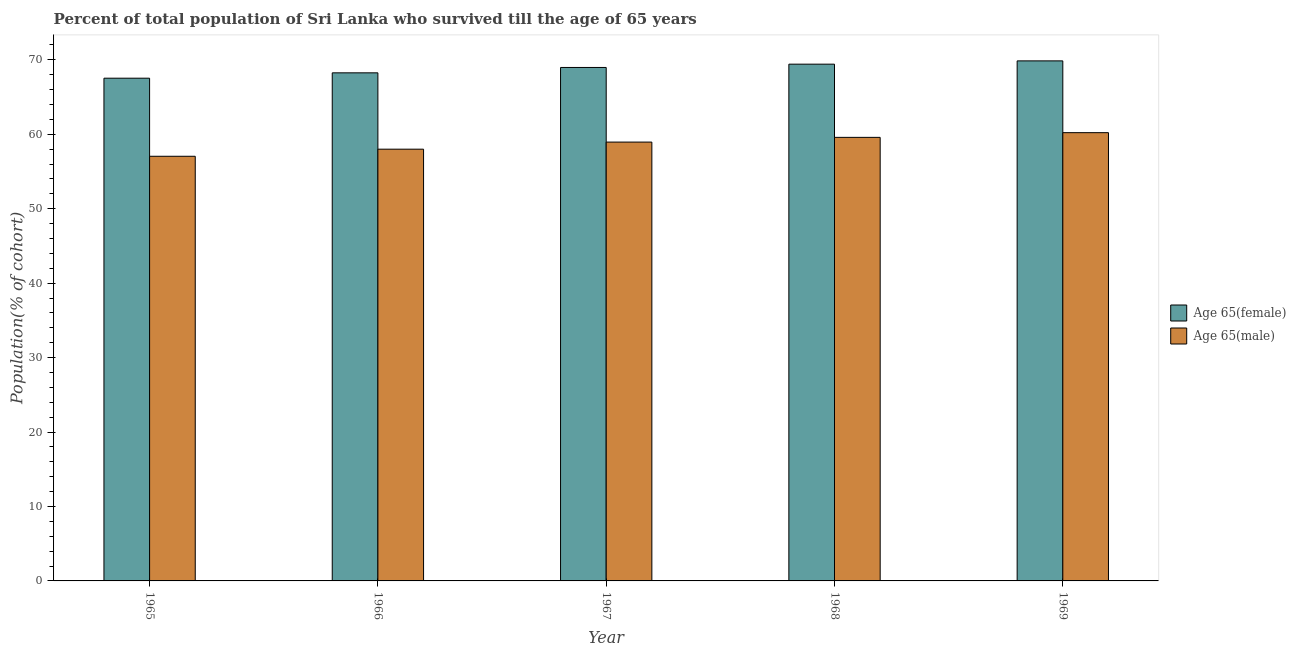How many different coloured bars are there?
Offer a very short reply. 2. How many groups of bars are there?
Give a very brief answer. 5. How many bars are there on the 3rd tick from the right?
Your answer should be compact. 2. What is the label of the 1st group of bars from the left?
Give a very brief answer. 1965. In how many cases, is the number of bars for a given year not equal to the number of legend labels?
Keep it short and to the point. 0. What is the percentage of male population who survived till age of 65 in 1965?
Your answer should be very brief. 57.04. Across all years, what is the maximum percentage of male population who survived till age of 65?
Your answer should be compact. 60.21. Across all years, what is the minimum percentage of female population who survived till age of 65?
Keep it short and to the point. 67.53. In which year was the percentage of male population who survived till age of 65 maximum?
Your response must be concise. 1969. In which year was the percentage of male population who survived till age of 65 minimum?
Your answer should be very brief. 1965. What is the total percentage of female population who survived till age of 65 in the graph?
Your response must be concise. 344.03. What is the difference between the percentage of male population who survived till age of 65 in 1967 and that in 1968?
Offer a very short reply. -0.63. What is the difference between the percentage of male population who survived till age of 65 in 1966 and the percentage of female population who survived till age of 65 in 1967?
Your response must be concise. -0.95. What is the average percentage of male population who survived till age of 65 per year?
Provide a short and direct response. 58.76. In how many years, is the percentage of female population who survived till age of 65 greater than 24 %?
Keep it short and to the point. 5. What is the ratio of the percentage of female population who survived till age of 65 in 1966 to that in 1968?
Your answer should be compact. 0.98. What is the difference between the highest and the second highest percentage of female population who survived till age of 65?
Your answer should be very brief. 0.44. What is the difference between the highest and the lowest percentage of male population who survived till age of 65?
Your response must be concise. 3.17. What does the 2nd bar from the left in 1965 represents?
Your answer should be compact. Age 65(male). What does the 2nd bar from the right in 1965 represents?
Make the answer very short. Age 65(female). Are all the bars in the graph horizontal?
Your answer should be very brief. No. Are the values on the major ticks of Y-axis written in scientific E-notation?
Give a very brief answer. No. Does the graph contain any zero values?
Your answer should be compact. No. How many legend labels are there?
Your answer should be compact. 2. How are the legend labels stacked?
Provide a short and direct response. Vertical. What is the title of the graph?
Offer a terse response. Percent of total population of Sri Lanka who survived till the age of 65 years. Does "Private credit bureau" appear as one of the legend labels in the graph?
Ensure brevity in your answer.  No. What is the label or title of the X-axis?
Offer a terse response. Year. What is the label or title of the Y-axis?
Offer a terse response. Population(% of cohort). What is the Population(% of cohort) in Age 65(female) in 1965?
Provide a short and direct response. 67.53. What is the Population(% of cohort) in Age 65(male) in 1965?
Provide a succinct answer. 57.04. What is the Population(% of cohort) in Age 65(female) in 1966?
Keep it short and to the point. 68.25. What is the Population(% of cohort) of Age 65(male) in 1966?
Your response must be concise. 58. What is the Population(% of cohort) of Age 65(female) in 1967?
Provide a succinct answer. 68.97. What is the Population(% of cohort) of Age 65(male) in 1967?
Provide a succinct answer. 58.95. What is the Population(% of cohort) of Age 65(female) in 1968?
Ensure brevity in your answer.  69.42. What is the Population(% of cohort) of Age 65(male) in 1968?
Give a very brief answer. 59.58. What is the Population(% of cohort) in Age 65(female) in 1969?
Your response must be concise. 69.86. What is the Population(% of cohort) in Age 65(male) in 1969?
Keep it short and to the point. 60.21. Across all years, what is the maximum Population(% of cohort) of Age 65(female)?
Your answer should be very brief. 69.86. Across all years, what is the maximum Population(% of cohort) in Age 65(male)?
Make the answer very short. 60.21. Across all years, what is the minimum Population(% of cohort) in Age 65(female)?
Your response must be concise. 67.53. Across all years, what is the minimum Population(% of cohort) in Age 65(male)?
Offer a terse response. 57.04. What is the total Population(% of cohort) in Age 65(female) in the graph?
Offer a terse response. 344.03. What is the total Population(% of cohort) of Age 65(male) in the graph?
Your answer should be compact. 293.79. What is the difference between the Population(% of cohort) in Age 65(female) in 1965 and that in 1966?
Provide a succinct answer. -0.72. What is the difference between the Population(% of cohort) in Age 65(male) in 1965 and that in 1966?
Provide a short and direct response. -0.95. What is the difference between the Population(% of cohort) of Age 65(female) in 1965 and that in 1967?
Offer a very short reply. -1.44. What is the difference between the Population(% of cohort) of Age 65(male) in 1965 and that in 1967?
Your answer should be very brief. -1.9. What is the difference between the Population(% of cohort) of Age 65(female) in 1965 and that in 1968?
Ensure brevity in your answer.  -1.88. What is the difference between the Population(% of cohort) of Age 65(male) in 1965 and that in 1968?
Give a very brief answer. -2.54. What is the difference between the Population(% of cohort) of Age 65(female) in 1965 and that in 1969?
Make the answer very short. -2.33. What is the difference between the Population(% of cohort) of Age 65(male) in 1965 and that in 1969?
Offer a terse response. -3.17. What is the difference between the Population(% of cohort) of Age 65(female) in 1966 and that in 1967?
Ensure brevity in your answer.  -0.72. What is the difference between the Population(% of cohort) in Age 65(male) in 1966 and that in 1967?
Provide a succinct answer. -0.95. What is the difference between the Population(% of cohort) of Age 65(female) in 1966 and that in 1968?
Ensure brevity in your answer.  -1.16. What is the difference between the Population(% of cohort) of Age 65(male) in 1966 and that in 1968?
Offer a terse response. -1.59. What is the difference between the Population(% of cohort) of Age 65(female) in 1966 and that in 1969?
Provide a short and direct response. -1.61. What is the difference between the Population(% of cohort) of Age 65(male) in 1966 and that in 1969?
Give a very brief answer. -2.22. What is the difference between the Population(% of cohort) in Age 65(female) in 1967 and that in 1968?
Give a very brief answer. -0.44. What is the difference between the Population(% of cohort) in Age 65(male) in 1967 and that in 1968?
Your answer should be compact. -0.63. What is the difference between the Population(% of cohort) in Age 65(female) in 1967 and that in 1969?
Provide a succinct answer. -0.88. What is the difference between the Population(% of cohort) in Age 65(male) in 1967 and that in 1969?
Ensure brevity in your answer.  -1.27. What is the difference between the Population(% of cohort) of Age 65(female) in 1968 and that in 1969?
Ensure brevity in your answer.  -0.44. What is the difference between the Population(% of cohort) in Age 65(male) in 1968 and that in 1969?
Your response must be concise. -0.63. What is the difference between the Population(% of cohort) in Age 65(female) in 1965 and the Population(% of cohort) in Age 65(male) in 1966?
Make the answer very short. 9.53. What is the difference between the Population(% of cohort) in Age 65(female) in 1965 and the Population(% of cohort) in Age 65(male) in 1967?
Your answer should be very brief. 8.58. What is the difference between the Population(% of cohort) of Age 65(female) in 1965 and the Population(% of cohort) of Age 65(male) in 1968?
Provide a succinct answer. 7.95. What is the difference between the Population(% of cohort) in Age 65(female) in 1965 and the Population(% of cohort) in Age 65(male) in 1969?
Ensure brevity in your answer.  7.32. What is the difference between the Population(% of cohort) in Age 65(female) in 1966 and the Population(% of cohort) in Age 65(male) in 1967?
Offer a very short reply. 9.3. What is the difference between the Population(% of cohort) of Age 65(female) in 1966 and the Population(% of cohort) of Age 65(male) in 1968?
Ensure brevity in your answer.  8.67. What is the difference between the Population(% of cohort) of Age 65(female) in 1966 and the Population(% of cohort) of Age 65(male) in 1969?
Give a very brief answer. 8.04. What is the difference between the Population(% of cohort) in Age 65(female) in 1967 and the Population(% of cohort) in Age 65(male) in 1968?
Give a very brief answer. 9.39. What is the difference between the Population(% of cohort) of Age 65(female) in 1967 and the Population(% of cohort) of Age 65(male) in 1969?
Provide a short and direct response. 8.76. What is the difference between the Population(% of cohort) of Age 65(female) in 1968 and the Population(% of cohort) of Age 65(male) in 1969?
Ensure brevity in your answer.  9.2. What is the average Population(% of cohort) in Age 65(female) per year?
Give a very brief answer. 68.81. What is the average Population(% of cohort) of Age 65(male) per year?
Offer a terse response. 58.76. In the year 1965, what is the difference between the Population(% of cohort) in Age 65(female) and Population(% of cohort) in Age 65(male)?
Provide a succinct answer. 10.49. In the year 1966, what is the difference between the Population(% of cohort) of Age 65(female) and Population(% of cohort) of Age 65(male)?
Keep it short and to the point. 10.26. In the year 1967, what is the difference between the Population(% of cohort) in Age 65(female) and Population(% of cohort) in Age 65(male)?
Offer a terse response. 10.02. In the year 1968, what is the difference between the Population(% of cohort) in Age 65(female) and Population(% of cohort) in Age 65(male)?
Make the answer very short. 9.83. In the year 1969, what is the difference between the Population(% of cohort) in Age 65(female) and Population(% of cohort) in Age 65(male)?
Offer a very short reply. 9.64. What is the ratio of the Population(% of cohort) in Age 65(male) in 1965 to that in 1966?
Ensure brevity in your answer.  0.98. What is the ratio of the Population(% of cohort) of Age 65(female) in 1965 to that in 1967?
Your response must be concise. 0.98. What is the ratio of the Population(% of cohort) in Age 65(female) in 1965 to that in 1968?
Provide a succinct answer. 0.97. What is the ratio of the Population(% of cohort) in Age 65(male) in 1965 to that in 1968?
Offer a terse response. 0.96. What is the ratio of the Population(% of cohort) in Age 65(female) in 1965 to that in 1969?
Offer a terse response. 0.97. What is the ratio of the Population(% of cohort) in Age 65(male) in 1965 to that in 1969?
Ensure brevity in your answer.  0.95. What is the ratio of the Population(% of cohort) of Age 65(female) in 1966 to that in 1967?
Your response must be concise. 0.99. What is the ratio of the Population(% of cohort) of Age 65(male) in 1966 to that in 1967?
Ensure brevity in your answer.  0.98. What is the ratio of the Population(% of cohort) in Age 65(female) in 1966 to that in 1968?
Provide a short and direct response. 0.98. What is the ratio of the Population(% of cohort) of Age 65(male) in 1966 to that in 1968?
Offer a terse response. 0.97. What is the ratio of the Population(% of cohort) in Age 65(male) in 1966 to that in 1969?
Provide a succinct answer. 0.96. What is the ratio of the Population(% of cohort) of Age 65(female) in 1967 to that in 1968?
Offer a terse response. 0.99. What is the ratio of the Population(% of cohort) of Age 65(female) in 1967 to that in 1969?
Provide a short and direct response. 0.99. What is the ratio of the Population(% of cohort) of Age 65(male) in 1967 to that in 1969?
Your answer should be very brief. 0.98. What is the ratio of the Population(% of cohort) in Age 65(female) in 1968 to that in 1969?
Offer a terse response. 0.99. What is the ratio of the Population(% of cohort) in Age 65(male) in 1968 to that in 1969?
Offer a very short reply. 0.99. What is the difference between the highest and the second highest Population(% of cohort) of Age 65(female)?
Offer a terse response. 0.44. What is the difference between the highest and the second highest Population(% of cohort) of Age 65(male)?
Your answer should be compact. 0.63. What is the difference between the highest and the lowest Population(% of cohort) in Age 65(female)?
Provide a short and direct response. 2.33. What is the difference between the highest and the lowest Population(% of cohort) in Age 65(male)?
Your answer should be compact. 3.17. 